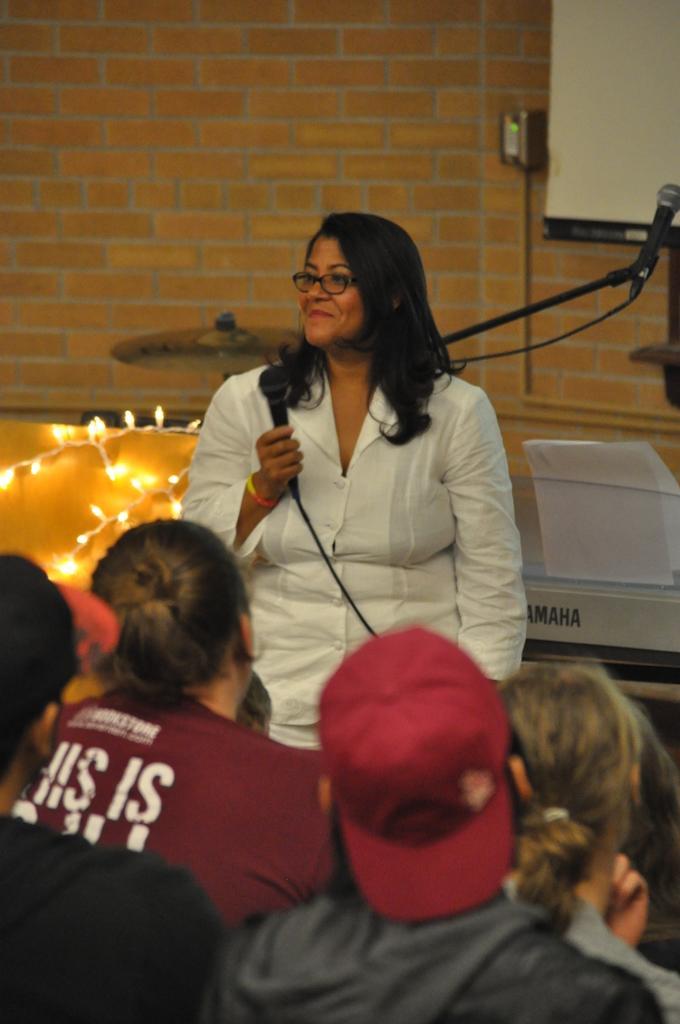Could you give a brief overview of what you see in this image? In this picture there is a woman wearing white color shirt is giving a speech on the microphone. In the front there are some boys sitting and listening to her. In the background there is brown color brick wall and some decorative lights. 